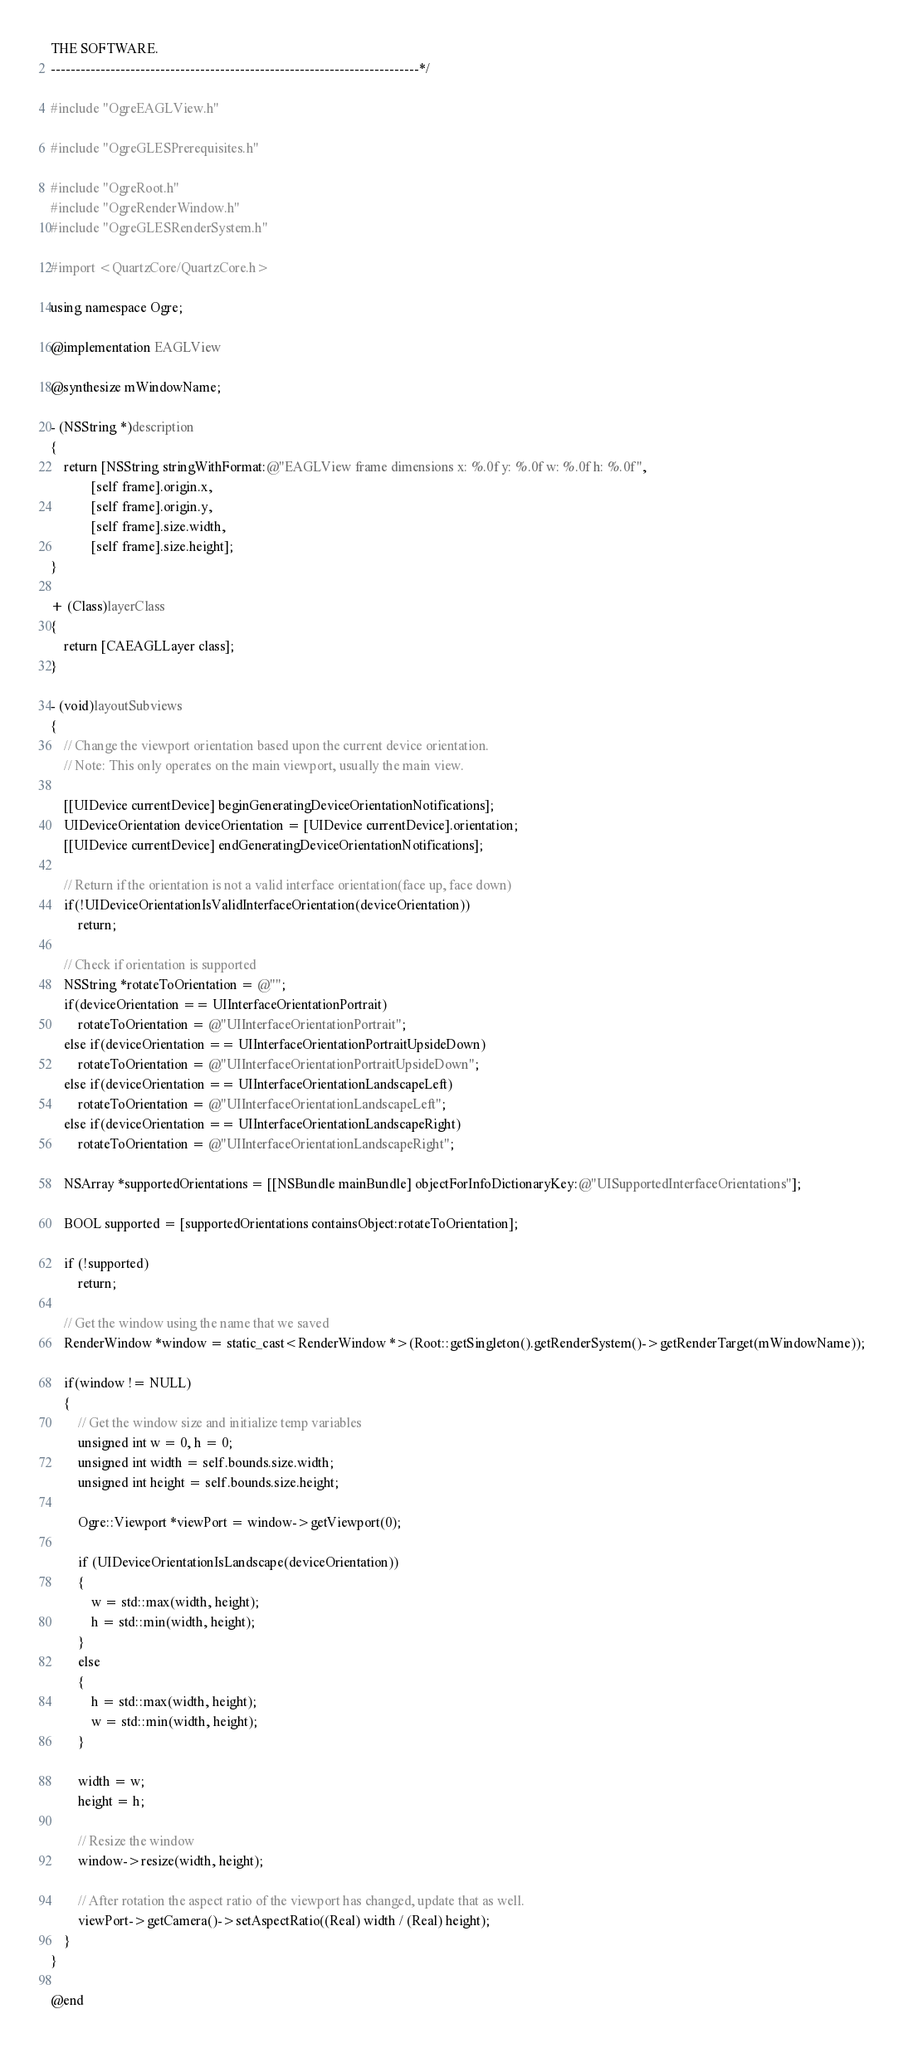Convert code to text. <code><loc_0><loc_0><loc_500><loc_500><_ObjectiveC_>THE SOFTWARE.
--------------------------------------------------------------------------*/

#include "OgreEAGLView.h"

#include "OgreGLESPrerequisites.h"

#include "OgreRoot.h"
#include "OgreRenderWindow.h"
#include "OgreGLESRenderSystem.h"

#import <QuartzCore/QuartzCore.h>

using namespace Ogre;

@implementation EAGLView

@synthesize mWindowName;

- (NSString *)description
{
    return [NSString stringWithFormat:@"EAGLView frame dimensions x: %.0f y: %.0f w: %.0f h: %.0f", 
            [self frame].origin.x,
            [self frame].origin.y,
            [self frame].size.width,
            [self frame].size.height];
}

+ (Class)layerClass
{
    return [CAEAGLLayer class];
}

- (void)layoutSubviews
{
    // Change the viewport orientation based upon the current device orientation.
    // Note: This only operates on the main viewport, usually the main view.

    [[UIDevice currentDevice] beginGeneratingDeviceOrientationNotifications];
    UIDeviceOrientation deviceOrientation = [UIDevice currentDevice].orientation;
    [[UIDevice currentDevice] endGeneratingDeviceOrientationNotifications];

    // Return if the orientation is not a valid interface orientation(face up, face down)
    if(!UIDeviceOrientationIsValidInterfaceOrientation(deviceOrientation))
        return;

    // Check if orientation is supported
    NSString *rotateToOrientation = @"";
    if(deviceOrientation == UIInterfaceOrientationPortrait)
        rotateToOrientation = @"UIInterfaceOrientationPortrait";
    else if(deviceOrientation == UIInterfaceOrientationPortraitUpsideDown)
        rotateToOrientation = @"UIInterfaceOrientationPortraitUpsideDown";
    else if(deviceOrientation == UIInterfaceOrientationLandscapeLeft)
        rotateToOrientation = @"UIInterfaceOrientationLandscapeLeft";
    else if(deviceOrientation == UIInterfaceOrientationLandscapeRight)
        rotateToOrientation = @"UIInterfaceOrientationLandscapeRight";

    NSArray *supportedOrientations = [[NSBundle mainBundle] objectForInfoDictionaryKey:@"UISupportedInterfaceOrientations"];

    BOOL supported = [supportedOrientations containsObject:rotateToOrientation];

    if (!supported)
        return;

    // Get the window using the name that we saved
    RenderWindow *window = static_cast<RenderWindow *>(Root::getSingleton().getRenderSystem()->getRenderTarget(mWindowName));

    if(window != NULL)
    {
        // Get the window size and initialize temp variables
        unsigned int w = 0, h = 0;
        unsigned int width = self.bounds.size.width;
        unsigned int height = self.bounds.size.height;

        Ogre::Viewport *viewPort = window->getViewport(0);

        if (UIDeviceOrientationIsLandscape(deviceOrientation))
        {
            w = std::max(width, height);
            h = std::min(width, height);
        }
        else
        {
            h = std::max(width, height);
            w = std::min(width, height);
        }

        width = w;
        height = h;

        // Resize the window
        window->resize(width, height);

        // After rotation the aspect ratio of the viewport has changed, update that as well.
        viewPort->getCamera()->setAspectRatio((Real) width / (Real) height);
    }
}

@end
</code> 